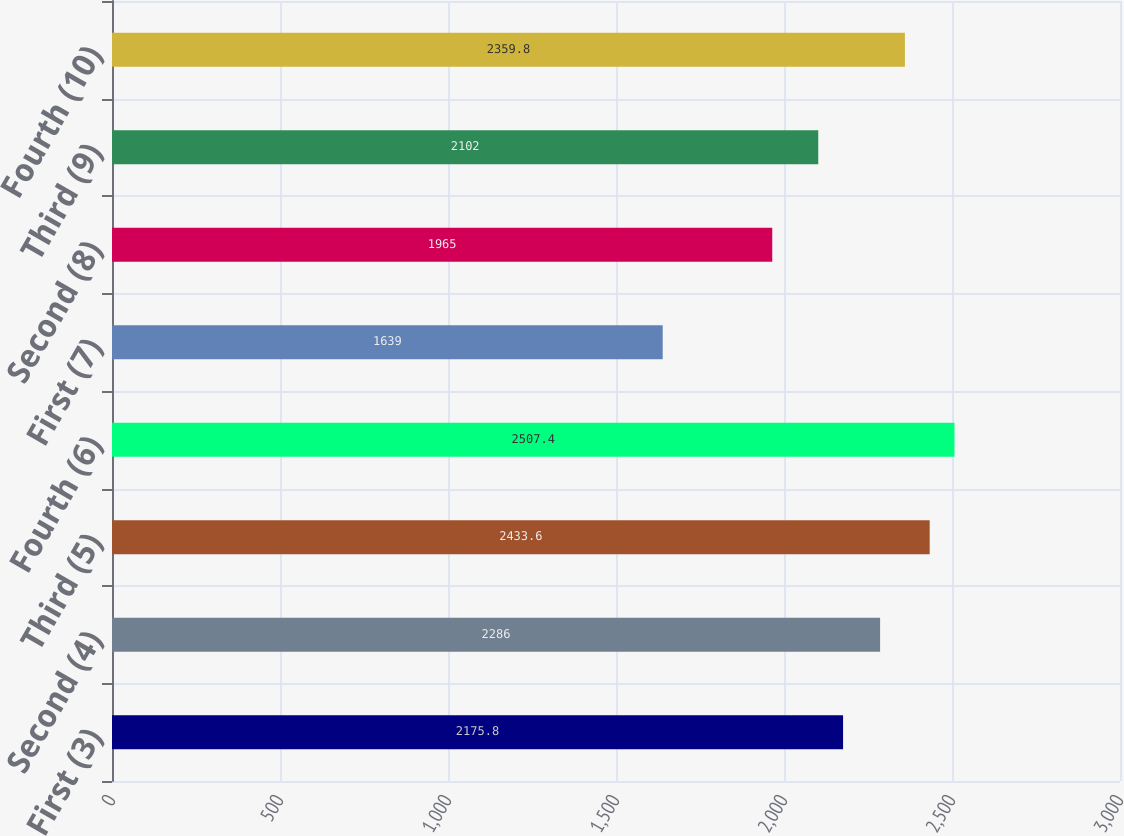Convert chart to OTSL. <chart><loc_0><loc_0><loc_500><loc_500><bar_chart><fcel>First (3)<fcel>Second (4)<fcel>Third (5)<fcel>Fourth (6)<fcel>First (7)<fcel>Second (8)<fcel>Third (9)<fcel>Fourth (10)<nl><fcel>2175.8<fcel>2286<fcel>2433.6<fcel>2507.4<fcel>1639<fcel>1965<fcel>2102<fcel>2359.8<nl></chart> 